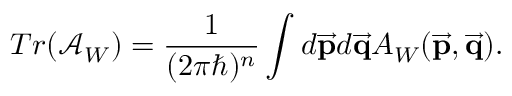Convert formula to latex. <formula><loc_0><loc_0><loc_500><loc_500>T r ( \mathcal { A } _ { W } ) = { \frac { 1 } { ( 2 \pi \hbar { ) } ^ { n } } } \int d \overrightarrow { p } d \overrightarrow { q } A _ { W } ( \overrightarrow { p } , \overrightarrow { q } ) .</formula> 